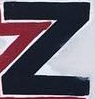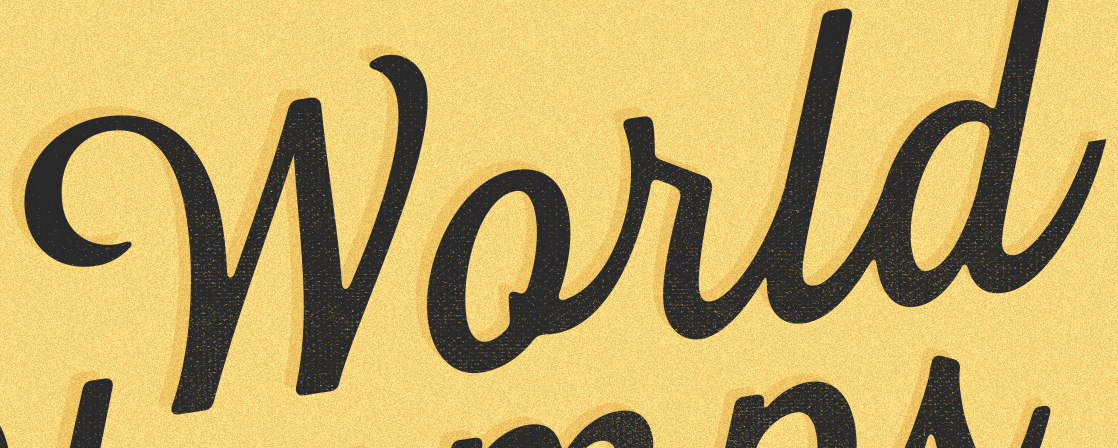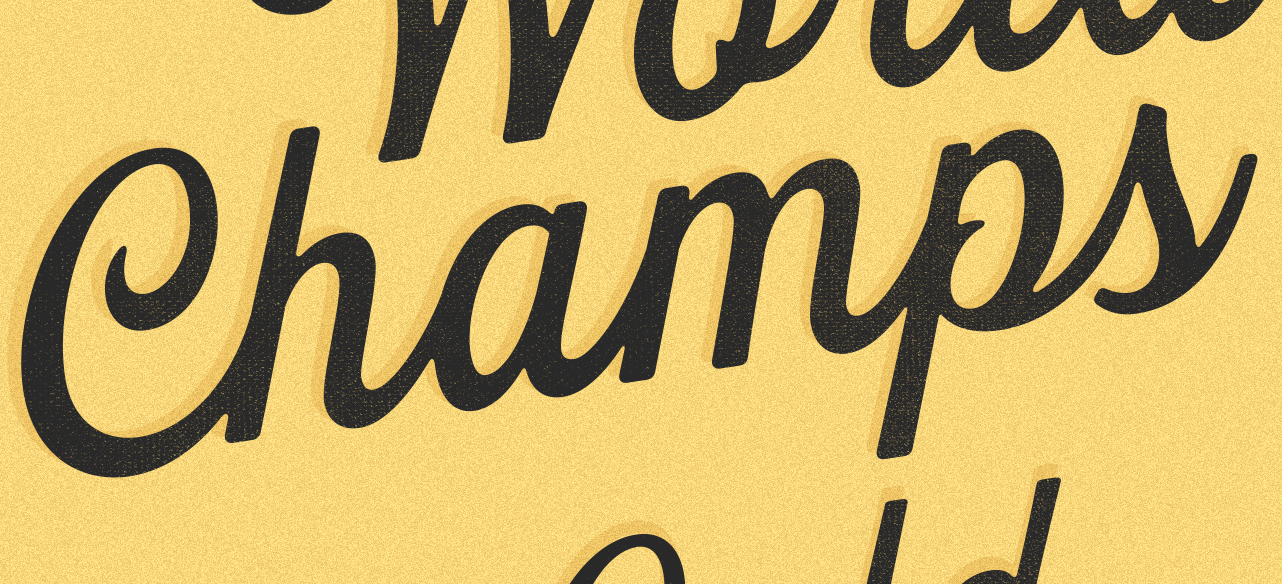What words can you see in these images in sequence, separated by a semicolon? Z; World; Champs 